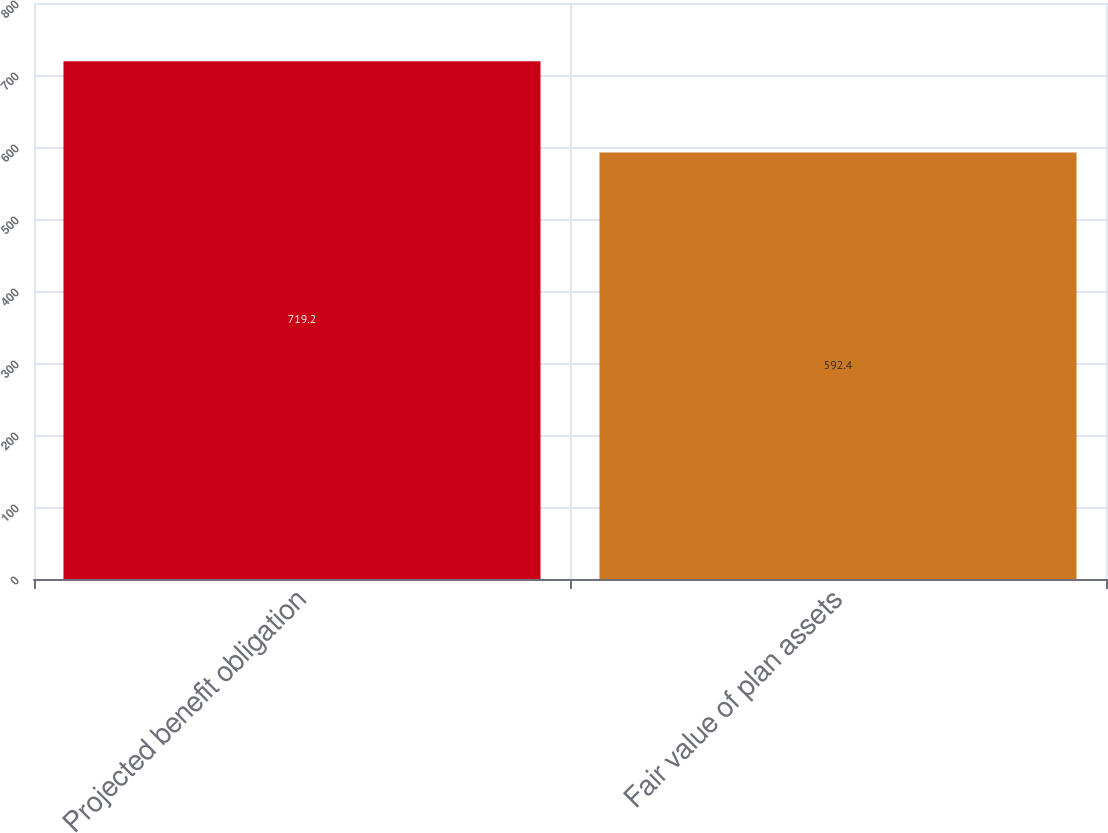Convert chart. <chart><loc_0><loc_0><loc_500><loc_500><bar_chart><fcel>Projected benefit obligation<fcel>Fair value of plan assets<nl><fcel>719.2<fcel>592.4<nl></chart> 